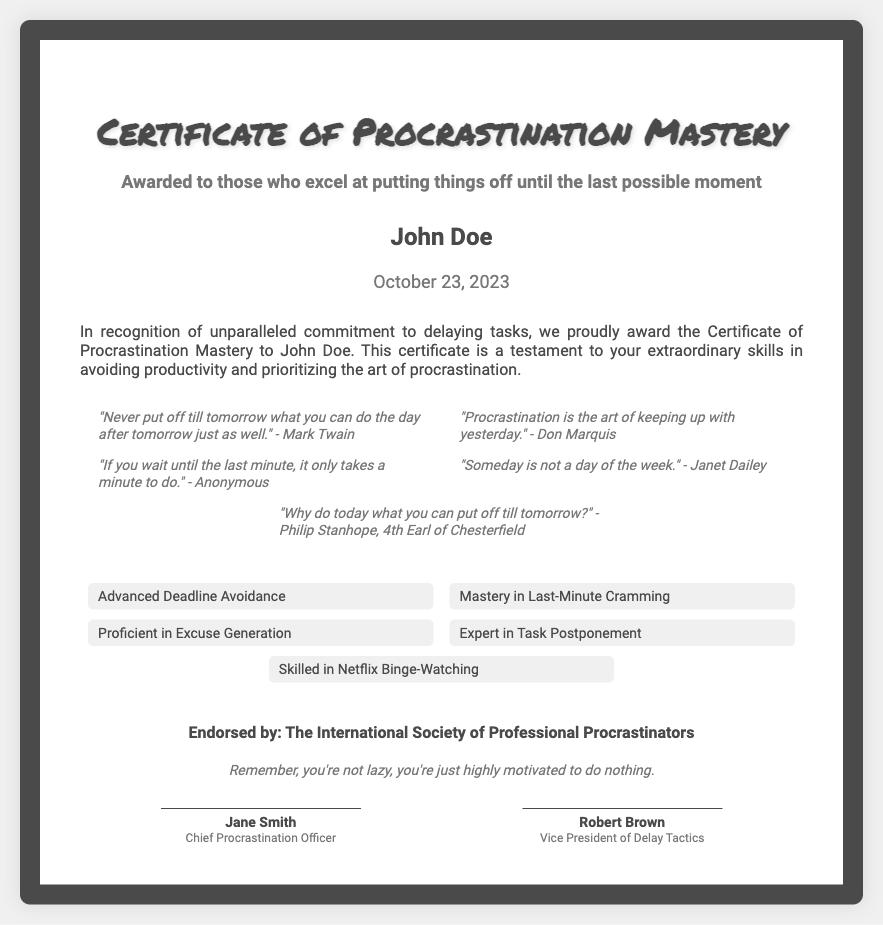What is the title of the certificate? The title is the main heading of the document and describes the certificate being awarded.
Answer: Certificate of Procrastination Mastery Who is the recipient of the certificate? The recipient is mentioned prominently below the title and serves to identify who is being awarded the certificate.
Answer: John Doe What is the date of the award? The date indicates when the certificate was awarded and is displayed below the recipient's name.
Answer: October 23, 2023 Who endorsed the certificate? The endorsement indicates the organization that recognizes the achievement and is presented towards the end of the document.
Answer: The International Society of Professional Procrastinators List one skill mentioned in the certificate. The skills listed represent the areas of expertise recognized by the certificate and exemplify procrastination abilities.
Answer: Advanced Deadline Avoidance What is one motivational quote included in the document? The document includes several motivational quotes that reflect the theme of procrastination, any of which could serve as an inspiration.
Answer: "Never put off till tomorrow what you can do the day after tomorrow just as well." - Mark Twain What are the titles of the signatories? The titles of the individuals who signed the document reflect their roles within the organization that issued the certificate.
Answer: Chief Procrastination Officer, Vice President of Delay Tactics What is the note at the bottom of the certificate? The note summarizes the overall message or theme of the certificate, providing a humorous perspective on procrastination.
Answer: Remember, you're not lazy, you're just highly motivated to do nothing 